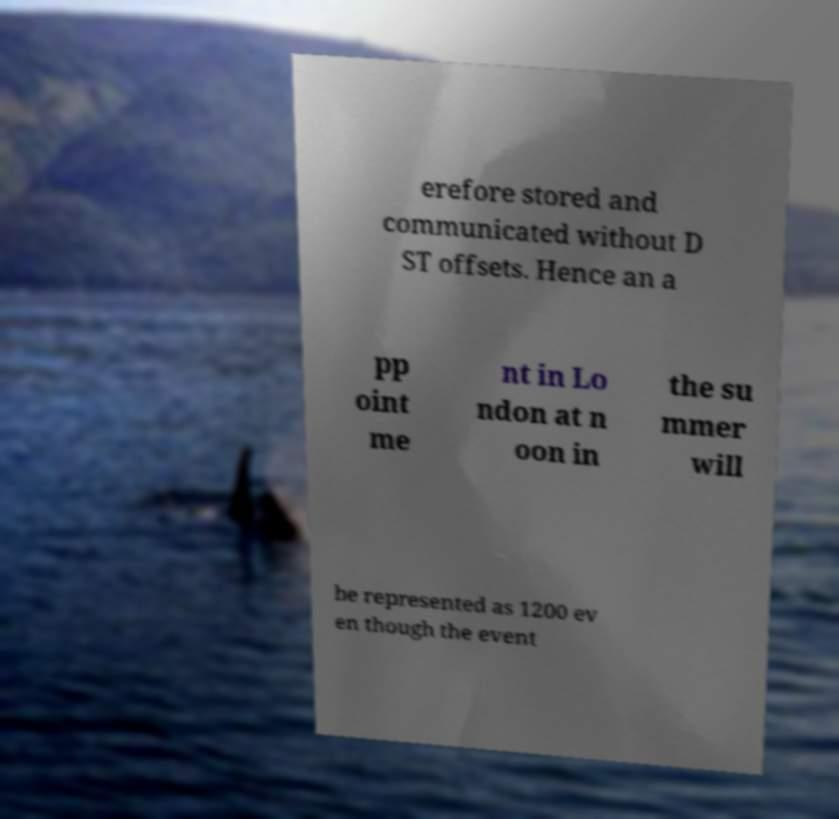What messages or text are displayed in this image? I need them in a readable, typed format. erefore stored and communicated without D ST offsets. Hence an a pp oint me nt in Lo ndon at n oon in the su mmer will be represented as 1200 ev en though the event 